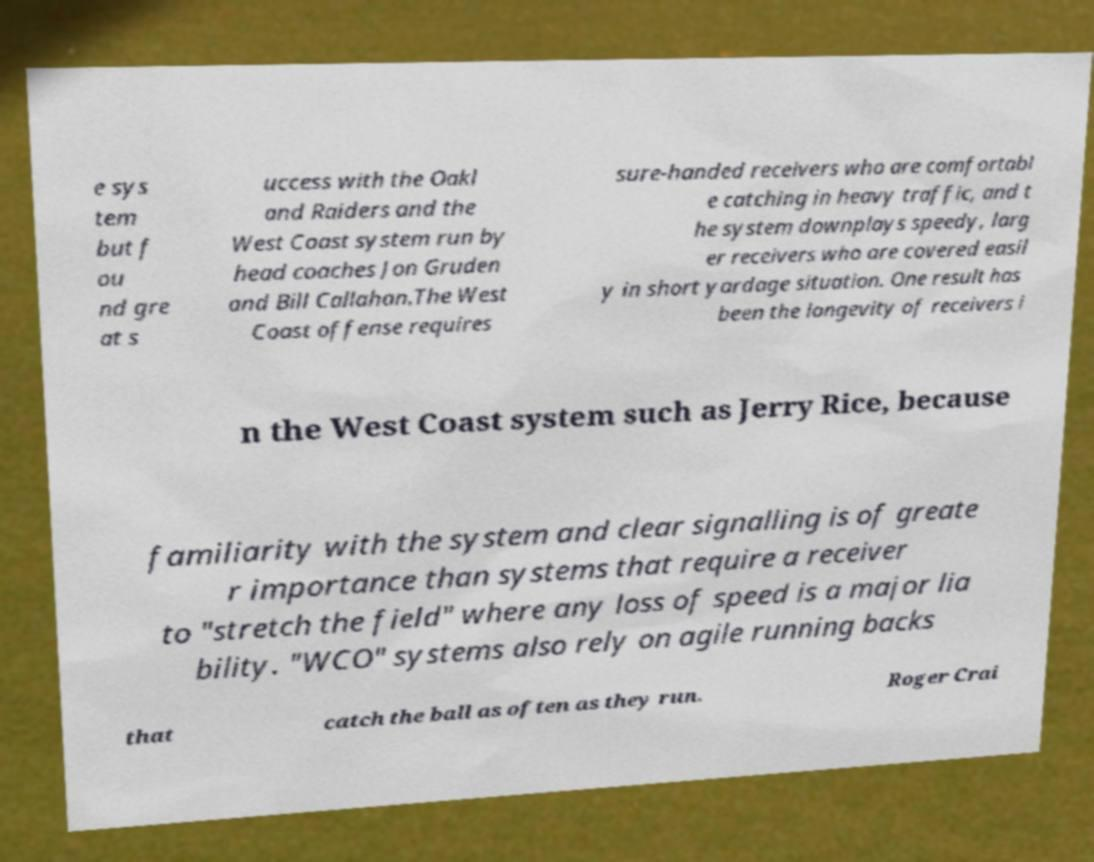For documentation purposes, I need the text within this image transcribed. Could you provide that? e sys tem but f ou nd gre at s uccess with the Oakl and Raiders and the West Coast system run by head coaches Jon Gruden and Bill Callahan.The West Coast offense requires sure-handed receivers who are comfortabl e catching in heavy traffic, and t he system downplays speedy, larg er receivers who are covered easil y in short yardage situation. One result has been the longevity of receivers i n the West Coast system such as Jerry Rice, because familiarity with the system and clear signalling is of greate r importance than systems that require a receiver to "stretch the field" where any loss of speed is a major lia bility. "WCO" systems also rely on agile running backs that catch the ball as often as they run. Roger Crai 